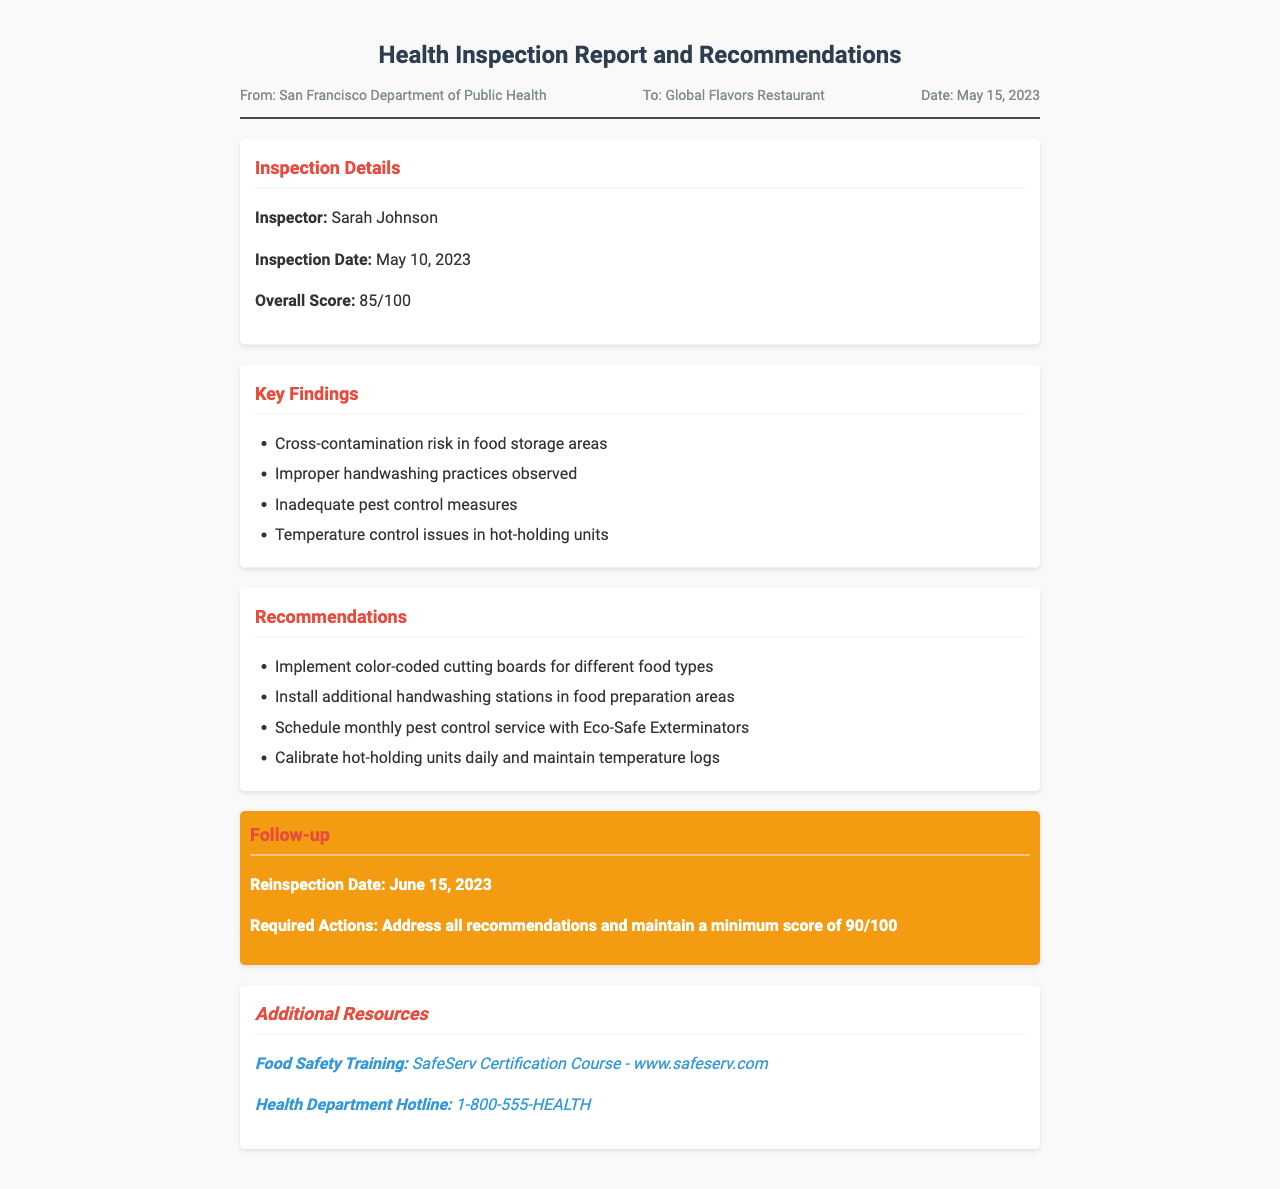What is the overall score? The overall score is found in the inspection details section of the document.
Answer: 85/100 Who is the inspector? The inspector's name is listed directly under the inspection details.
Answer: Sarah Johnson What date was the inspection conducted? The inspection date is specified in the inspection details section.
Answer: May 10, 2023 What is the required score for the follow-up? The required score is mentioned in the follow-up section of the document.
Answer: 90/100 What is one key finding from the inspection? Key findings are listed in the document under the key findings section; any of them can be cited.
Answer: Cross-contamination risk in food storage areas What is one recommendation given in the report? Recommendations are outlined in their own section in the document, and any of them can be used as an answer.
Answer: Implement color-coded cutting boards for different food types What is the reinspection date? The reinspection date is clearly indicated in the follow-up section of the document.
Answer: June 15, 2023 What training course is mentioned as an additional resource? The additional resource section includes reference to the training course provided.
Answer: SafeServ Certification Course 